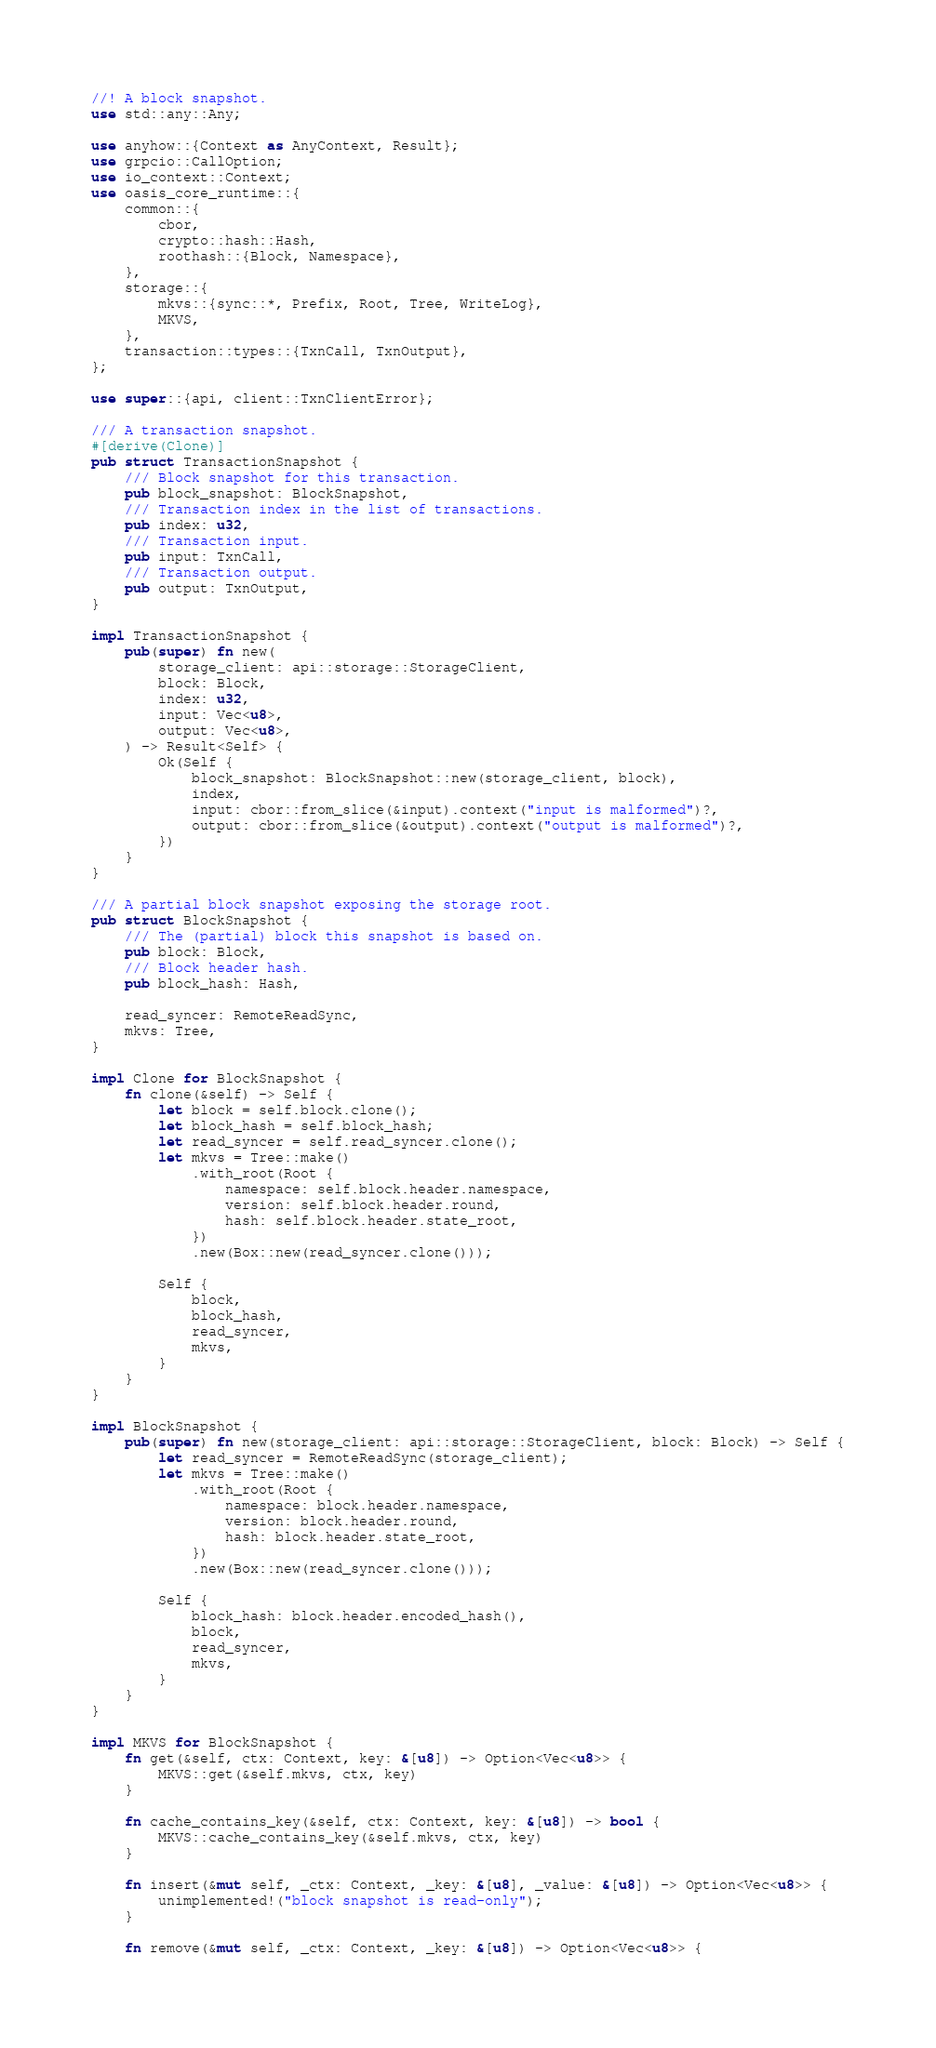Convert code to text. <code><loc_0><loc_0><loc_500><loc_500><_Rust_>//! A block snapshot.
use std::any::Any;

use anyhow::{Context as AnyContext, Result};
use grpcio::CallOption;
use io_context::Context;
use oasis_core_runtime::{
    common::{
        cbor,
        crypto::hash::Hash,
        roothash::{Block, Namespace},
    },
    storage::{
        mkvs::{sync::*, Prefix, Root, Tree, WriteLog},
        MKVS,
    },
    transaction::types::{TxnCall, TxnOutput},
};

use super::{api, client::TxnClientError};

/// A transaction snapshot.
#[derive(Clone)]
pub struct TransactionSnapshot {
    /// Block snapshot for this transaction.
    pub block_snapshot: BlockSnapshot,
    /// Transaction index in the list of transactions.
    pub index: u32,
    /// Transaction input.
    pub input: TxnCall,
    /// Transaction output.
    pub output: TxnOutput,
}

impl TransactionSnapshot {
    pub(super) fn new(
        storage_client: api::storage::StorageClient,
        block: Block,
        index: u32,
        input: Vec<u8>,
        output: Vec<u8>,
    ) -> Result<Self> {
        Ok(Self {
            block_snapshot: BlockSnapshot::new(storage_client, block),
            index,
            input: cbor::from_slice(&input).context("input is malformed")?,
            output: cbor::from_slice(&output).context("output is malformed")?,
        })
    }
}

/// A partial block snapshot exposing the storage root.
pub struct BlockSnapshot {
    /// The (partial) block this snapshot is based on.
    pub block: Block,
    /// Block header hash.
    pub block_hash: Hash,

    read_syncer: RemoteReadSync,
    mkvs: Tree,
}

impl Clone for BlockSnapshot {
    fn clone(&self) -> Self {
        let block = self.block.clone();
        let block_hash = self.block_hash;
        let read_syncer = self.read_syncer.clone();
        let mkvs = Tree::make()
            .with_root(Root {
                namespace: self.block.header.namespace,
                version: self.block.header.round,
                hash: self.block.header.state_root,
            })
            .new(Box::new(read_syncer.clone()));

        Self {
            block,
            block_hash,
            read_syncer,
            mkvs,
        }
    }
}

impl BlockSnapshot {
    pub(super) fn new(storage_client: api::storage::StorageClient, block: Block) -> Self {
        let read_syncer = RemoteReadSync(storage_client);
        let mkvs = Tree::make()
            .with_root(Root {
                namespace: block.header.namespace,
                version: block.header.round,
                hash: block.header.state_root,
            })
            .new(Box::new(read_syncer.clone()));

        Self {
            block_hash: block.header.encoded_hash(),
            block,
            read_syncer,
            mkvs,
        }
    }
}

impl MKVS for BlockSnapshot {
    fn get(&self, ctx: Context, key: &[u8]) -> Option<Vec<u8>> {
        MKVS::get(&self.mkvs, ctx, key)
    }

    fn cache_contains_key(&self, ctx: Context, key: &[u8]) -> bool {
        MKVS::cache_contains_key(&self.mkvs, ctx, key)
    }

    fn insert(&mut self, _ctx: Context, _key: &[u8], _value: &[u8]) -> Option<Vec<u8>> {
        unimplemented!("block snapshot is read-only");
    }

    fn remove(&mut self, _ctx: Context, _key: &[u8]) -> Option<Vec<u8>> {</code> 